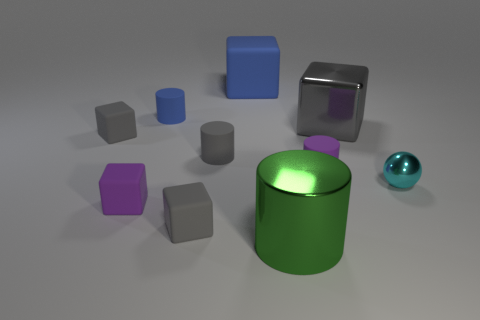Subtract all cyan cylinders. How many gray cubes are left? 3 Subtract all purple blocks. How many blocks are left? 4 Subtract all purple blocks. How many blocks are left? 4 Subtract 1 cylinders. How many cylinders are left? 3 Subtract all yellow blocks. Subtract all red spheres. How many blocks are left? 5 Subtract all spheres. How many objects are left? 9 Add 4 small purple rubber things. How many small purple rubber things exist? 6 Subtract 0 purple spheres. How many objects are left? 10 Subtract all small blue rubber objects. Subtract all tiny blue things. How many objects are left? 8 Add 7 big gray cubes. How many big gray cubes are left? 8 